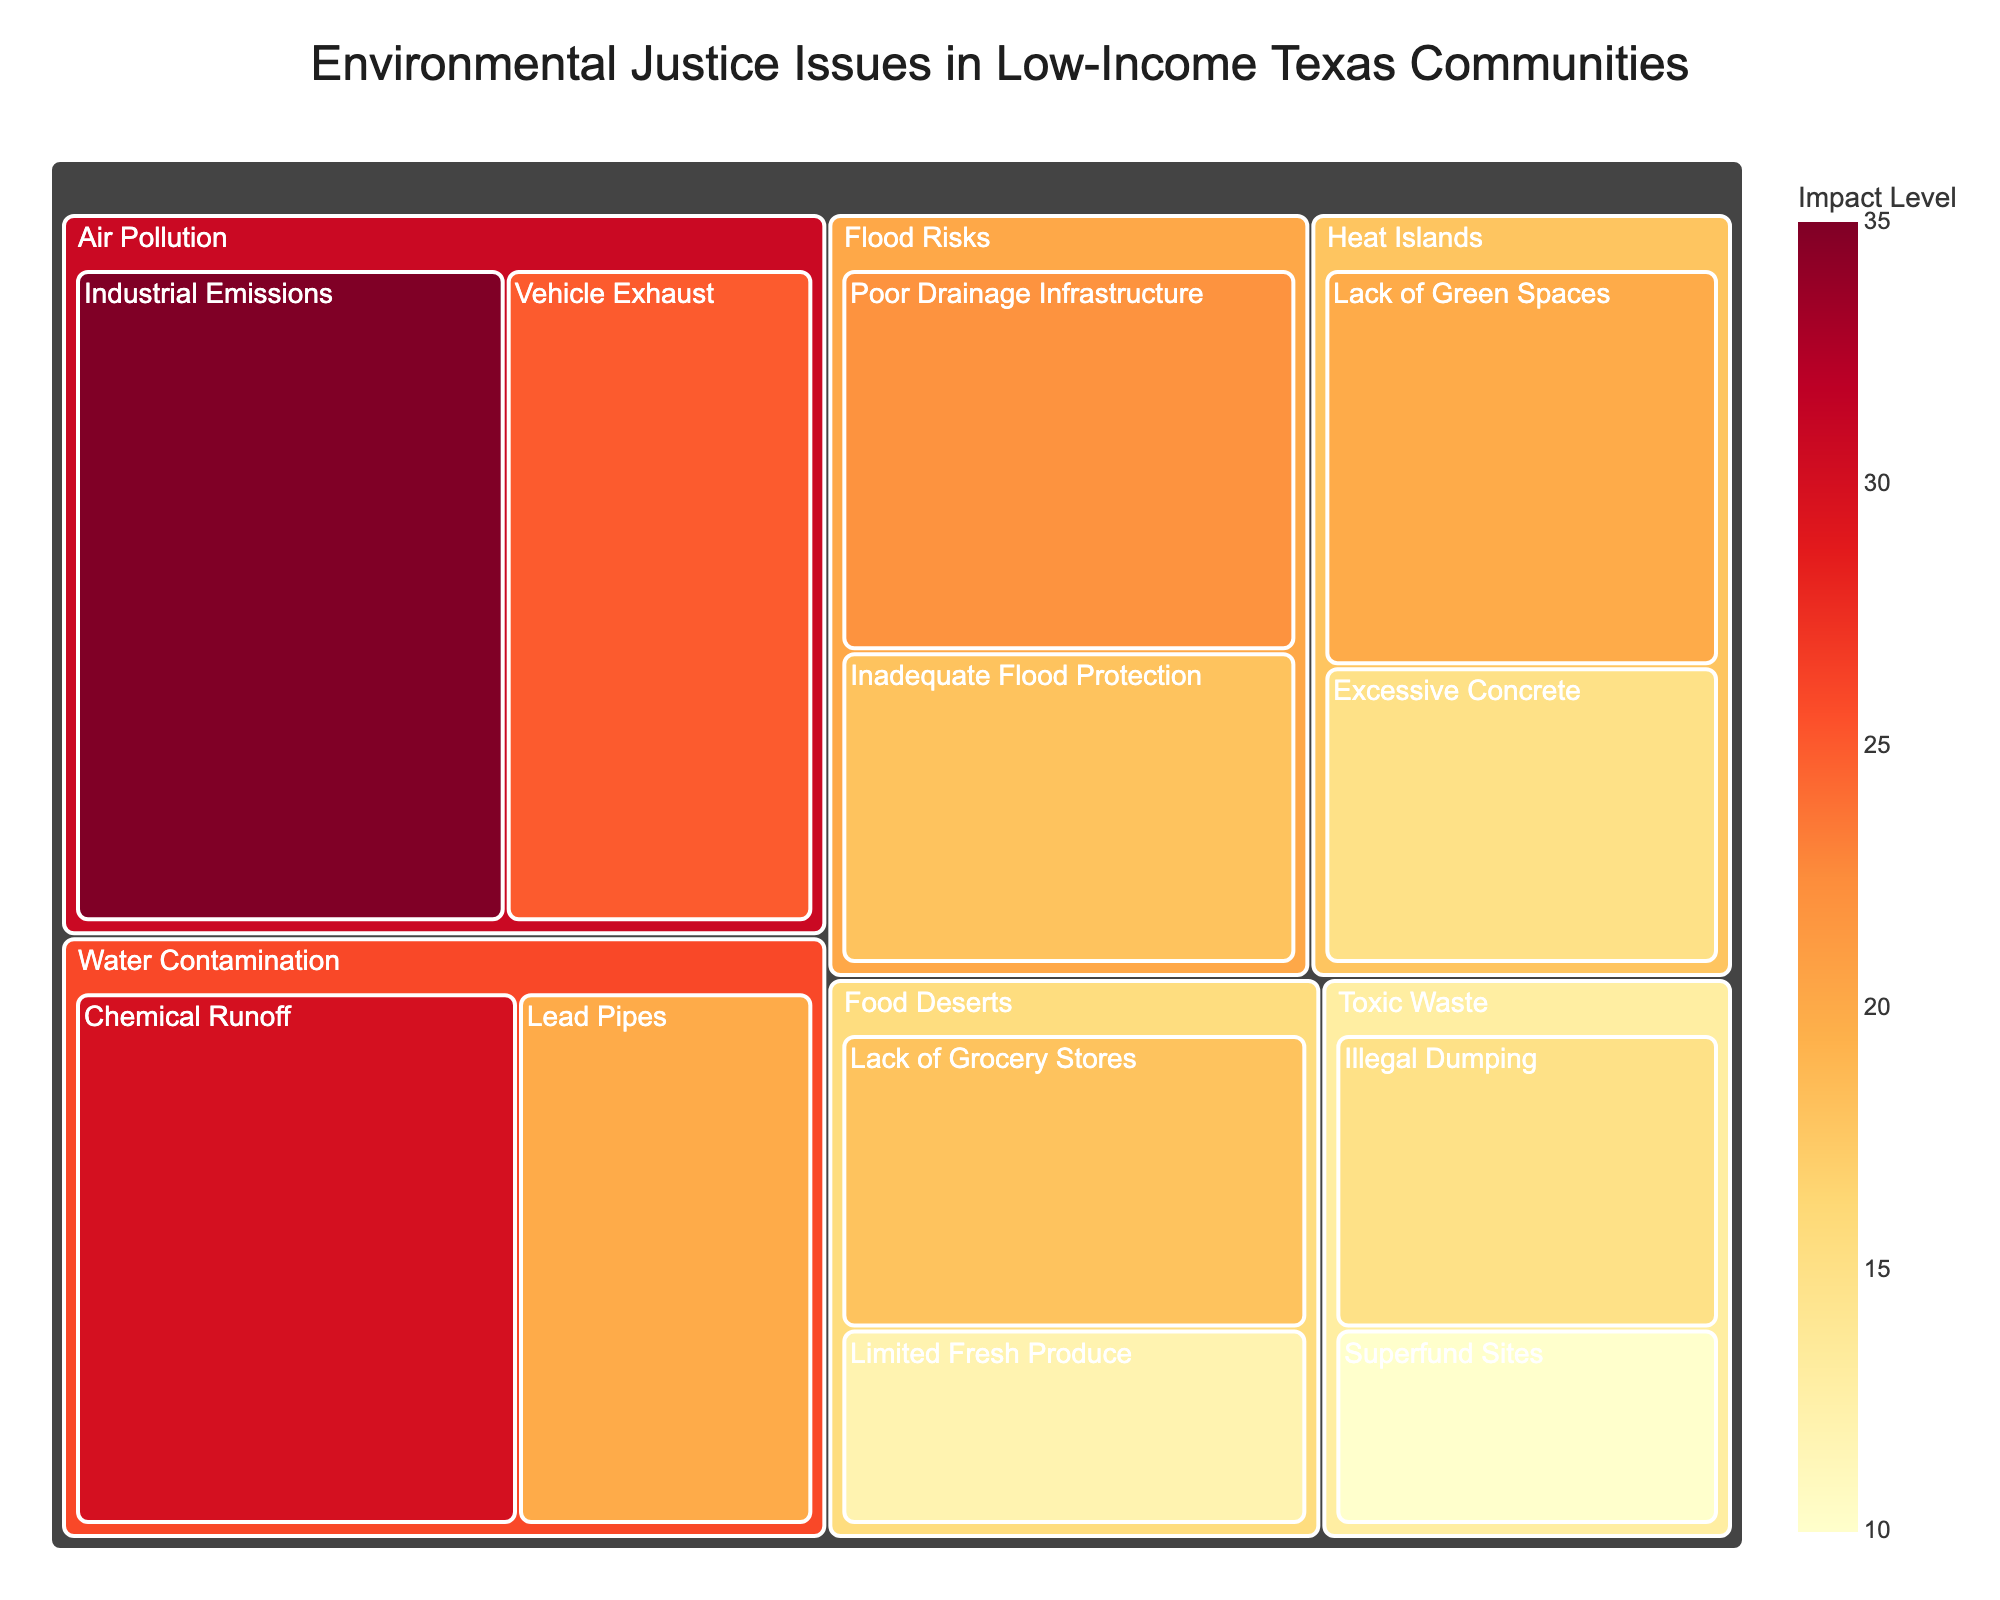what's the most prominent environmental issue by impact? Looking at the treemap, the largest section (brightest color) represents the issue with the highest impact. In this case, "Air Pollution: Industrial Emissions" occupies the most space with a value of 35.
Answer: Air Pollution: Industrial Emissions How do the impacts of "Vehicle Exhaust" and "Chemical Runoff" compare? Referring to the treemap, "Vehicle Exhaust" in the Air Pollution category has a value of 25, while "Chemical Runoff" in the Water Contamination category has a value of 30. Thus, Chemical Runoff has a greater impact.
Answer: Chemical Runoff has a greater impact What is the combined impact of issues associated with air pollution? Summing the values under the Air Pollution category: Industrial Emissions (35) + Vehicle Exhaust (25), we get 60.
Answer: 60 Which category has the most subcategories? By examining the treemap, each main category and its subdivisions, Air Pollution, Water Contamination, Toxic Waste, Food Deserts, Flood Risks, and Heat Islands, all seem to have two subcategories.
Answer: Multiple categories have the same number of subcategories What are the subcategories in the "Toxic Waste" category, and what are their impact values? The treemap shows "Illegal Dumping" and "Superfund Sites" as subcategories under Toxic Waste with values of 15 and 10, respectively.
Answer: Illegal Dumping (15), Superfund Sites (10) Which environmental justice issue related to "Heat Islands" has the lesser impact? Comparing the values within the Heat Islands category, "Excessive Concrete" has a value of 15, which is less than "Lack of Green Spaces" with a value of 20.
Answer: Excessive Concrete What is the total impact value for issues related to "Flood Risks"? Summing the values under the Flood Risks category: Poor Drainage Infrastructure (22) + Inadequate Flood Protection (18), we get 40.
Answer: 40 What color range is used to represent the impact levels in the treemap? Observing the color coding on the treemap, the color range progresses from yellow to orange to red.
Answer: Yellow to Red 